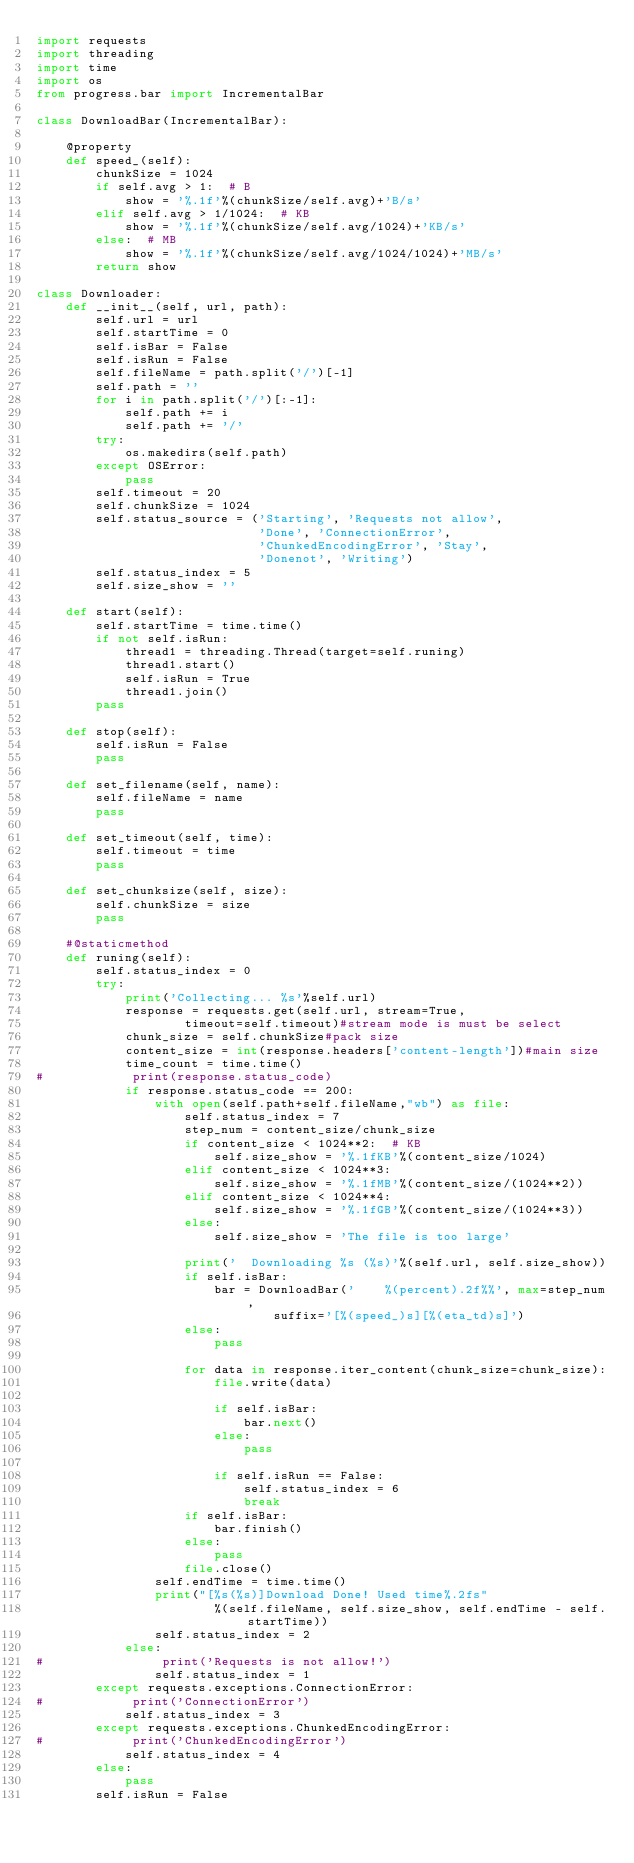<code> <loc_0><loc_0><loc_500><loc_500><_Python_>import requests
import threading
import time
import os
from progress.bar import IncrementalBar

class DownloadBar(IncrementalBar):
    
    @property
    def speed_(self):
        chunkSize = 1024
        if self.avg > 1:  # B
            show = '%.1f'%(chunkSize/self.avg)+'B/s'
        elif self.avg > 1/1024:  # KB
            show = '%.1f'%(chunkSize/self.avg/1024)+'KB/s'
        else:  # MB
            show = '%.1f'%(chunkSize/self.avg/1024/1024)+'MB/s'
        return show

class Downloader:
    def __init__(self, url, path):
        self.url = url
        self.startTime = 0
        self.isBar = False
        self.isRun = False
        self.fileName = path.split('/')[-1]
        self.path = ''
        for i in path.split('/')[:-1]:
            self.path += i
            self.path += '/'
        try:
            os.makedirs(self.path)
        except OSError:
            pass
        self.timeout = 20
        self.chunkSize = 1024
        self.status_source = ('Starting', 'Requests not allow', 
                              'Done', 'ConnectionError', 
                              'ChunkedEncodingError', 'Stay', 
                              'Donenot', 'Writing')
        self.status_index = 5
        self.size_show = ''
    
    def start(self):
        self.startTime = time.time()
        if not self.isRun:
            thread1 = threading.Thread(target=self.runing)
            thread1.start()
            self.isRun = True
            thread1.join()
        pass
    
    def stop(self):
        self.isRun = False
        pass

    def set_filename(self, name):
        self.fileName = name
        pass

    def set_timeout(self, time):
        self.timeout = time
        pass

    def set_chunksize(self, size):
        self.chunkSize = size
        pass
    
    #@staticmethod
    def runing(self):
        self.status_index = 0
        try:
            print('Collecting... %s'%self.url)
            response = requests.get(self.url, stream=True, 
                    timeout=self.timeout)#stream mode is must be select
            chunk_size = self.chunkSize#pack size
            content_size = int(response.headers['content-length'])#main size
            time_count = time.time()
#            print(response.status_code)
            if response.status_code == 200:
                with open(self.path+self.fileName,"wb") as file:
                    self.status_index = 7
                    step_num = content_size/chunk_size
                    if content_size < 1024**2:  # KB
                        self.size_show = '%.1fKB'%(content_size/1024)
                    elif content_size < 1024**3:
                        self.size_show = '%.1fMB'%(content_size/(1024**2))
                    elif content_size < 1024**4:
                        self.size_show = '%.1fGB'%(content_size/(1024**3))
                    else:
                        self.size_show = 'The file is too large'

                    print('  Downloading %s (%s)'%(self.url, self.size_show))
                    if self.isBar:
                        bar = DownloadBar('    %(percent).2f%%', max=step_num, 
                                suffix='[%(speed_)s][%(eta_td)s]')
                    else:
                        pass

                    for data in response.iter_content(chunk_size=chunk_size):
                        file.write(data)

                        if self.isBar:
                            bar.next()
                        else:
                            pass

                        if self.isRun == False:
                            self.status_index = 6
                            break
                    if self.isBar:
                        bar.finish()
                    else:
                        pass
                    file.close()
                self.endTime = time.time()
                print("[%s(%s)]Download Done! Used time%.2fs"
                        %(self.fileName, self.size_show, self.endTime - self.startTime))
                self.status_index = 2
            else:
#                print('Requests is not allow!')
                self.status_index = 1
        except requests.exceptions.ConnectionError:
#            print('ConnectionError')
            self.status_index = 3
        except requests.exceptions.ChunkedEncodingError:
#            print('ChunkedEncodingError')
            self.status_index = 4
        else:
            pass
        self.isRun = False

</code> 